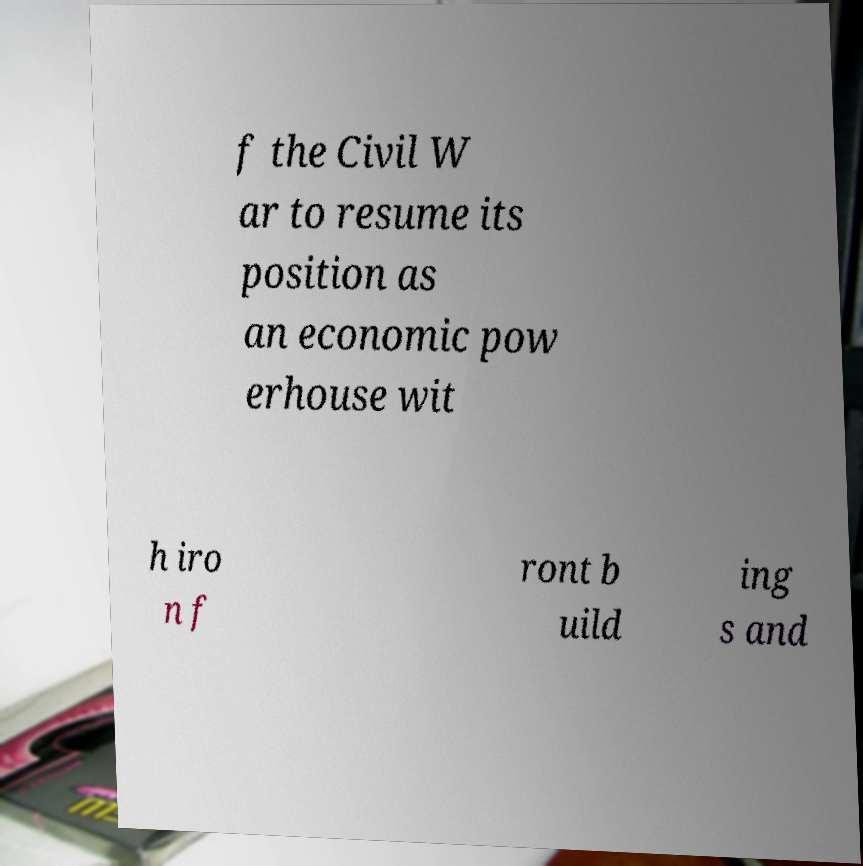What messages or text are displayed in this image? I need them in a readable, typed format. f the Civil W ar to resume its position as an economic pow erhouse wit h iro n f ront b uild ing s and 